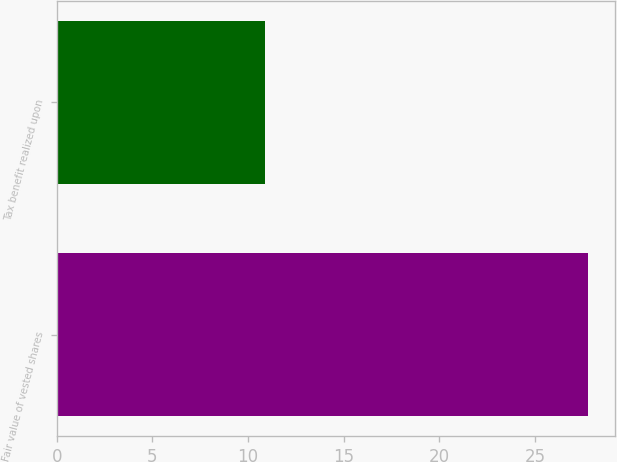Convert chart. <chart><loc_0><loc_0><loc_500><loc_500><bar_chart><fcel>Fair value of vested shares<fcel>Tax benefit realized upon<nl><fcel>27.8<fcel>10.9<nl></chart> 